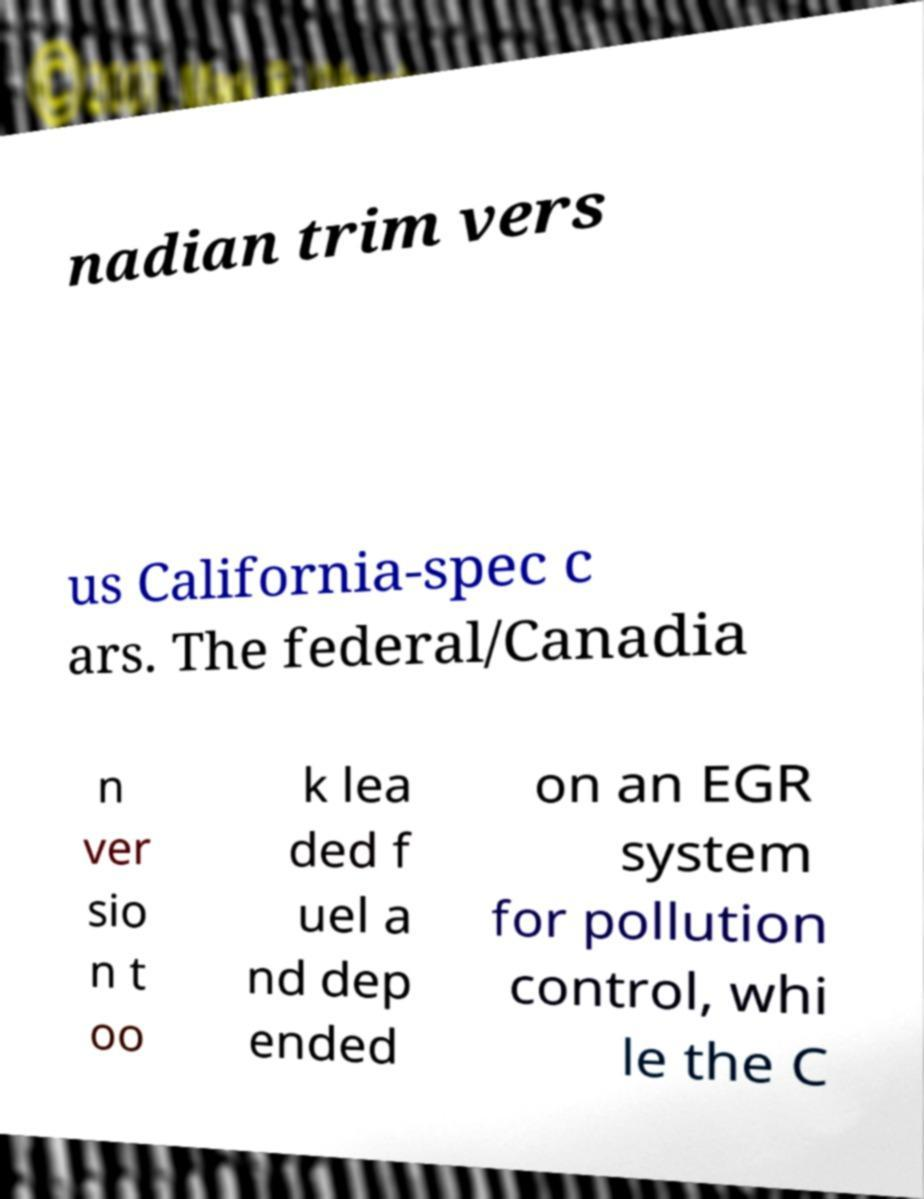Please read and relay the text visible in this image. What does it say? nadian trim vers us California-spec c ars. The federal/Canadia n ver sio n t oo k lea ded f uel a nd dep ended on an EGR system for pollution control, whi le the C 